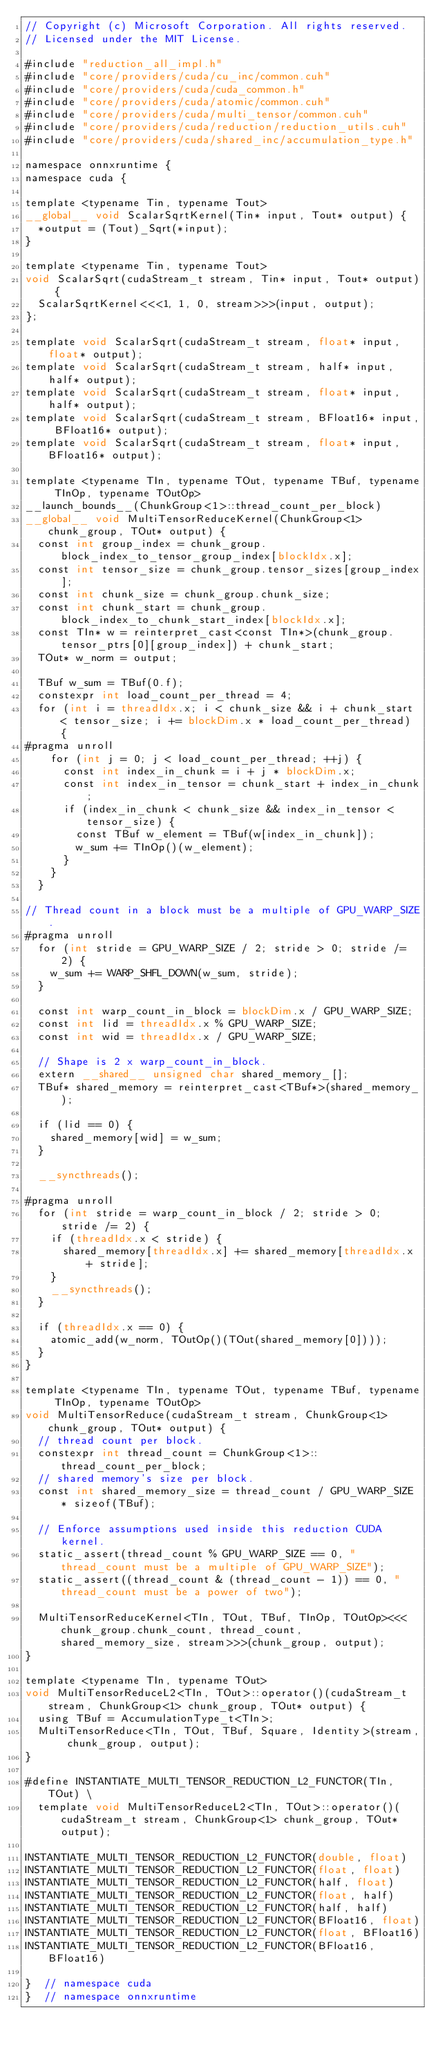Convert code to text. <code><loc_0><loc_0><loc_500><loc_500><_Cuda_>// Copyright (c) Microsoft Corporation. All rights reserved.
// Licensed under the MIT License.

#include "reduction_all_impl.h"
#include "core/providers/cuda/cu_inc/common.cuh"
#include "core/providers/cuda/cuda_common.h"
#include "core/providers/cuda/atomic/common.cuh"
#include "core/providers/cuda/multi_tensor/common.cuh"
#include "core/providers/cuda/reduction/reduction_utils.cuh"
#include "core/providers/cuda/shared_inc/accumulation_type.h"

namespace onnxruntime {
namespace cuda {

template <typename Tin, typename Tout>
__global__ void ScalarSqrtKernel(Tin* input, Tout* output) {
  *output = (Tout)_Sqrt(*input);
}

template <typename Tin, typename Tout>
void ScalarSqrt(cudaStream_t stream, Tin* input, Tout* output) {
  ScalarSqrtKernel<<<1, 1, 0, stream>>>(input, output);
};

template void ScalarSqrt(cudaStream_t stream, float* input, float* output);
template void ScalarSqrt(cudaStream_t stream, half* input, half* output);
template void ScalarSqrt(cudaStream_t stream, float* input, half* output);
template void ScalarSqrt(cudaStream_t stream, BFloat16* input, BFloat16* output);
template void ScalarSqrt(cudaStream_t stream, float* input, BFloat16* output);

template <typename TIn, typename TOut, typename TBuf, typename TInOp, typename TOutOp>
__launch_bounds__(ChunkGroup<1>::thread_count_per_block)
__global__ void MultiTensorReduceKernel(ChunkGroup<1> chunk_group, TOut* output) {
  const int group_index = chunk_group.block_index_to_tensor_group_index[blockIdx.x];
  const int tensor_size = chunk_group.tensor_sizes[group_index];
  const int chunk_size = chunk_group.chunk_size;
  const int chunk_start = chunk_group.block_index_to_chunk_start_index[blockIdx.x];
  const TIn* w = reinterpret_cast<const TIn*>(chunk_group.tensor_ptrs[0][group_index]) + chunk_start;
  TOut* w_norm = output;

  TBuf w_sum = TBuf(0.f);
  constexpr int load_count_per_thread = 4;
  for (int i = threadIdx.x; i < chunk_size && i + chunk_start < tensor_size; i += blockDim.x * load_count_per_thread) {
#pragma unroll
    for (int j = 0; j < load_count_per_thread; ++j) {
      const int index_in_chunk = i + j * blockDim.x;
      const int index_in_tensor = chunk_start + index_in_chunk;
      if (index_in_chunk < chunk_size && index_in_tensor < tensor_size) {
        const TBuf w_element = TBuf(w[index_in_chunk]);
        w_sum += TInOp()(w_element);
      }
    }
  }

// Thread count in a block must be a multiple of GPU_WARP_SIZE.
#pragma unroll
  for (int stride = GPU_WARP_SIZE / 2; stride > 0; stride /= 2) {
    w_sum += WARP_SHFL_DOWN(w_sum, stride);
  }

  const int warp_count_in_block = blockDim.x / GPU_WARP_SIZE;
  const int lid = threadIdx.x % GPU_WARP_SIZE;
  const int wid = threadIdx.x / GPU_WARP_SIZE;

  // Shape is 2 x warp_count_in_block.
  extern __shared__ unsigned char shared_memory_[];
  TBuf* shared_memory = reinterpret_cast<TBuf*>(shared_memory_);

  if (lid == 0) {
    shared_memory[wid] = w_sum;
  }

  __syncthreads();

#pragma unroll
  for (int stride = warp_count_in_block / 2; stride > 0; stride /= 2) {
    if (threadIdx.x < stride) {
      shared_memory[threadIdx.x] += shared_memory[threadIdx.x + stride];
    }
    __syncthreads();
  }

  if (threadIdx.x == 0) {
    atomic_add(w_norm, TOutOp()(TOut(shared_memory[0])));
  }
}

template <typename TIn, typename TOut, typename TBuf, typename TInOp, typename TOutOp>
void MultiTensorReduce(cudaStream_t stream, ChunkGroup<1> chunk_group, TOut* output) {
  // thread count per block.
  constexpr int thread_count = ChunkGroup<1>::thread_count_per_block;
  // shared memory's size per block.
  const int shared_memory_size = thread_count / GPU_WARP_SIZE * sizeof(TBuf);

  // Enforce assumptions used inside this reduction CUDA kernel.
  static_assert(thread_count % GPU_WARP_SIZE == 0, "thread_count must be a multiple of GPU_WARP_SIZE");
  static_assert((thread_count & (thread_count - 1)) == 0, "thread_count must be a power of two");

  MultiTensorReduceKernel<TIn, TOut, TBuf, TInOp, TOutOp><<<chunk_group.chunk_count, thread_count, shared_memory_size, stream>>>(chunk_group, output);
}

template <typename TIn, typename TOut>
void MultiTensorReduceL2<TIn, TOut>::operator()(cudaStream_t stream, ChunkGroup<1> chunk_group, TOut* output) {
  using TBuf = AccumulationType_t<TIn>;
  MultiTensorReduce<TIn, TOut, TBuf, Square, Identity>(stream, chunk_group, output);
}

#define INSTANTIATE_MULTI_TENSOR_REDUCTION_L2_FUNCTOR(TIn, TOut) \
  template void MultiTensorReduceL2<TIn, TOut>::operator()(cudaStream_t stream, ChunkGroup<1> chunk_group, TOut* output);

INSTANTIATE_MULTI_TENSOR_REDUCTION_L2_FUNCTOR(double, float)
INSTANTIATE_MULTI_TENSOR_REDUCTION_L2_FUNCTOR(float, float)
INSTANTIATE_MULTI_TENSOR_REDUCTION_L2_FUNCTOR(half, float)
INSTANTIATE_MULTI_TENSOR_REDUCTION_L2_FUNCTOR(float, half)
INSTANTIATE_MULTI_TENSOR_REDUCTION_L2_FUNCTOR(half, half)
INSTANTIATE_MULTI_TENSOR_REDUCTION_L2_FUNCTOR(BFloat16, float)
INSTANTIATE_MULTI_TENSOR_REDUCTION_L2_FUNCTOR(float, BFloat16)
INSTANTIATE_MULTI_TENSOR_REDUCTION_L2_FUNCTOR(BFloat16, BFloat16)

}  // namespace cuda
}  // namespace onnxruntime</code> 